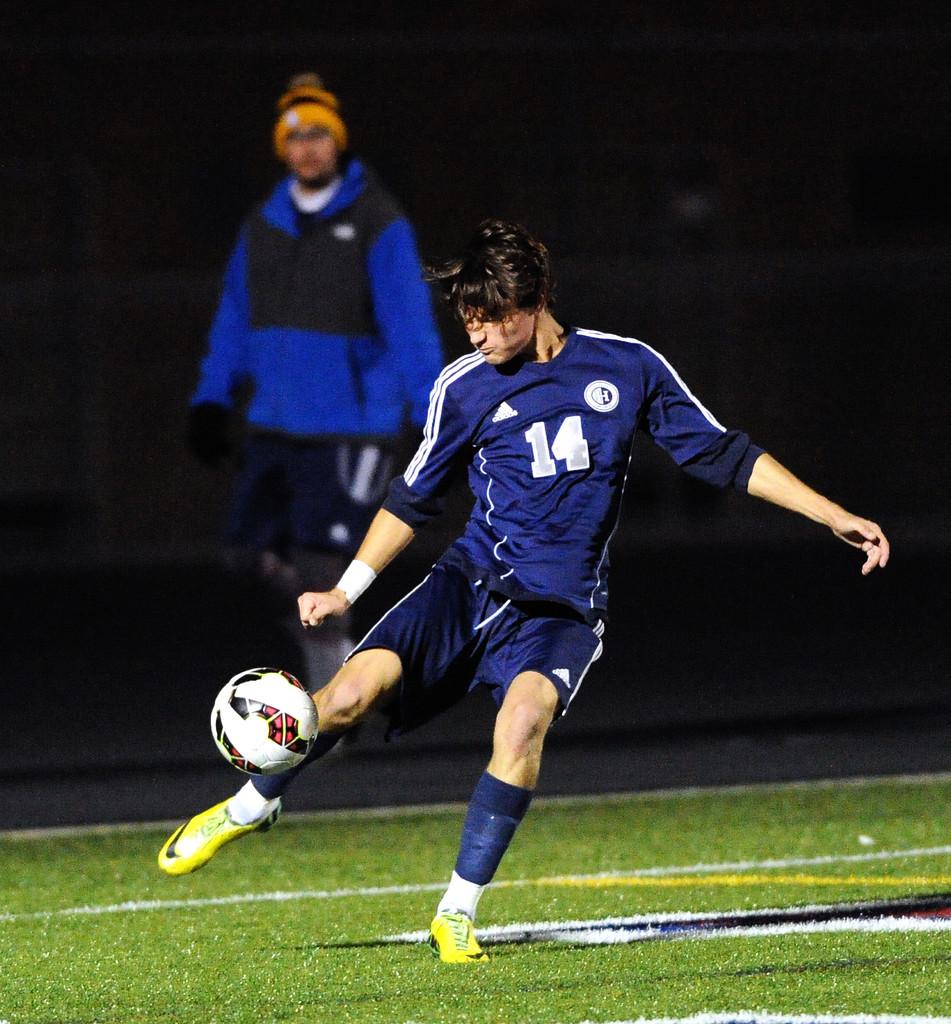What number is this player?
Give a very brief answer. 14. What brand is the jersey?
Ensure brevity in your answer.  Adidas. 